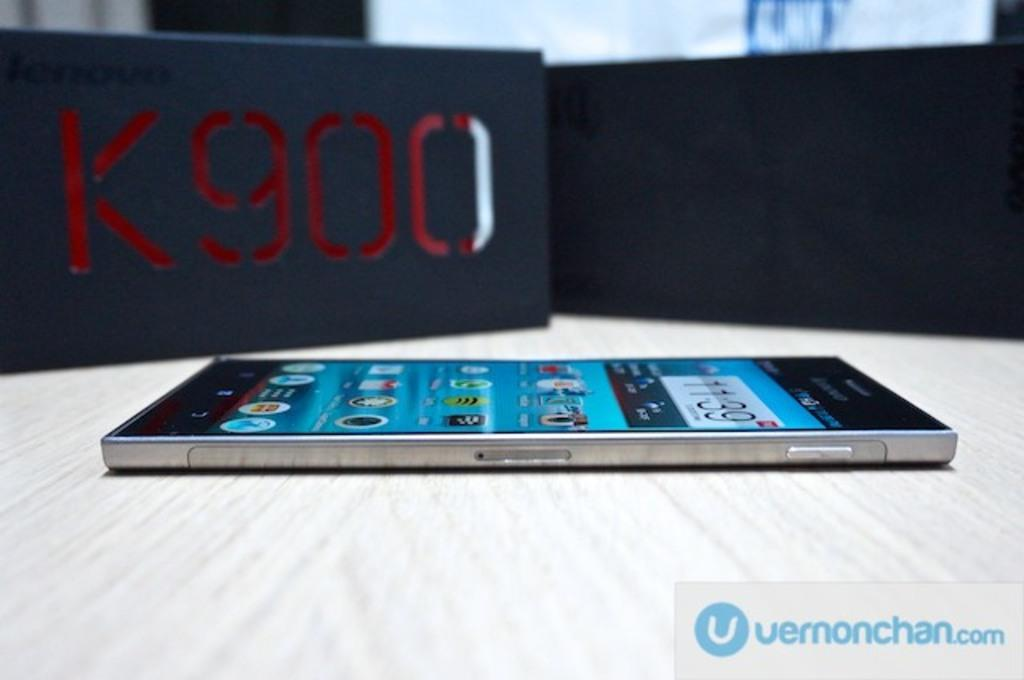<image>
Give a short and clear explanation of the subsequent image. A smart phone rests on a surface next to a K900 box. 